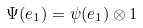<formula> <loc_0><loc_0><loc_500><loc_500>\Psi ( e _ { 1 } ) = \psi ( e _ { 1 } ) \otimes 1</formula> 